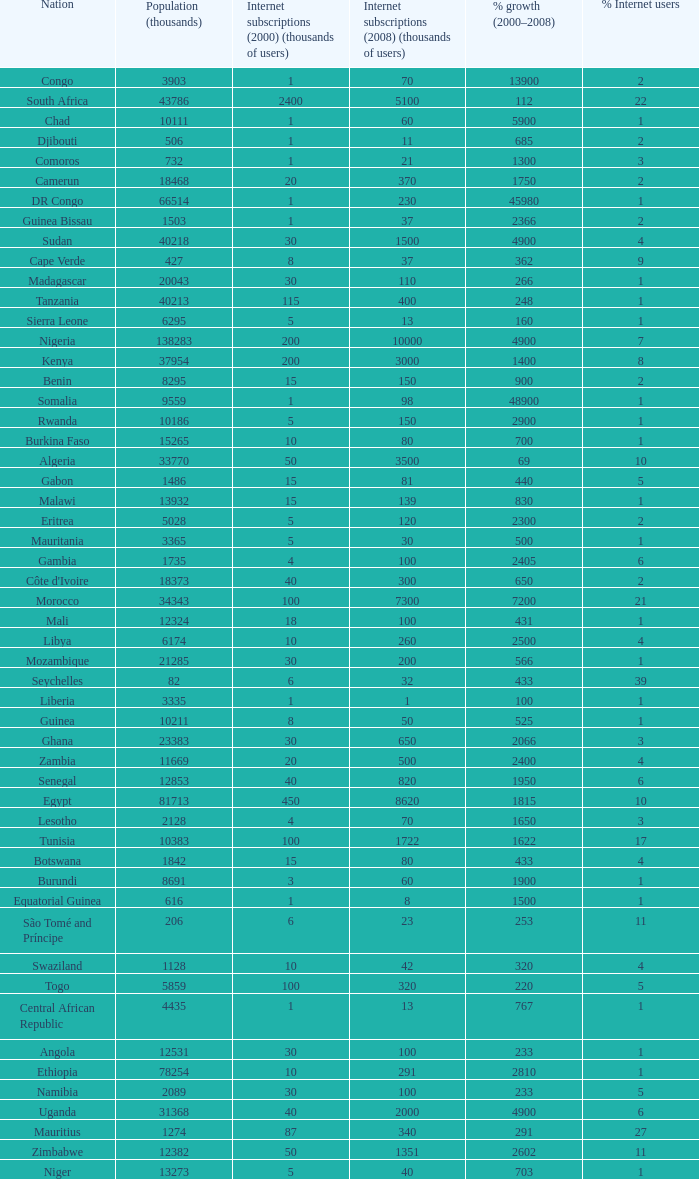What is the percentage of growth in 2000-2008 in ethiopia? 2810.0. 